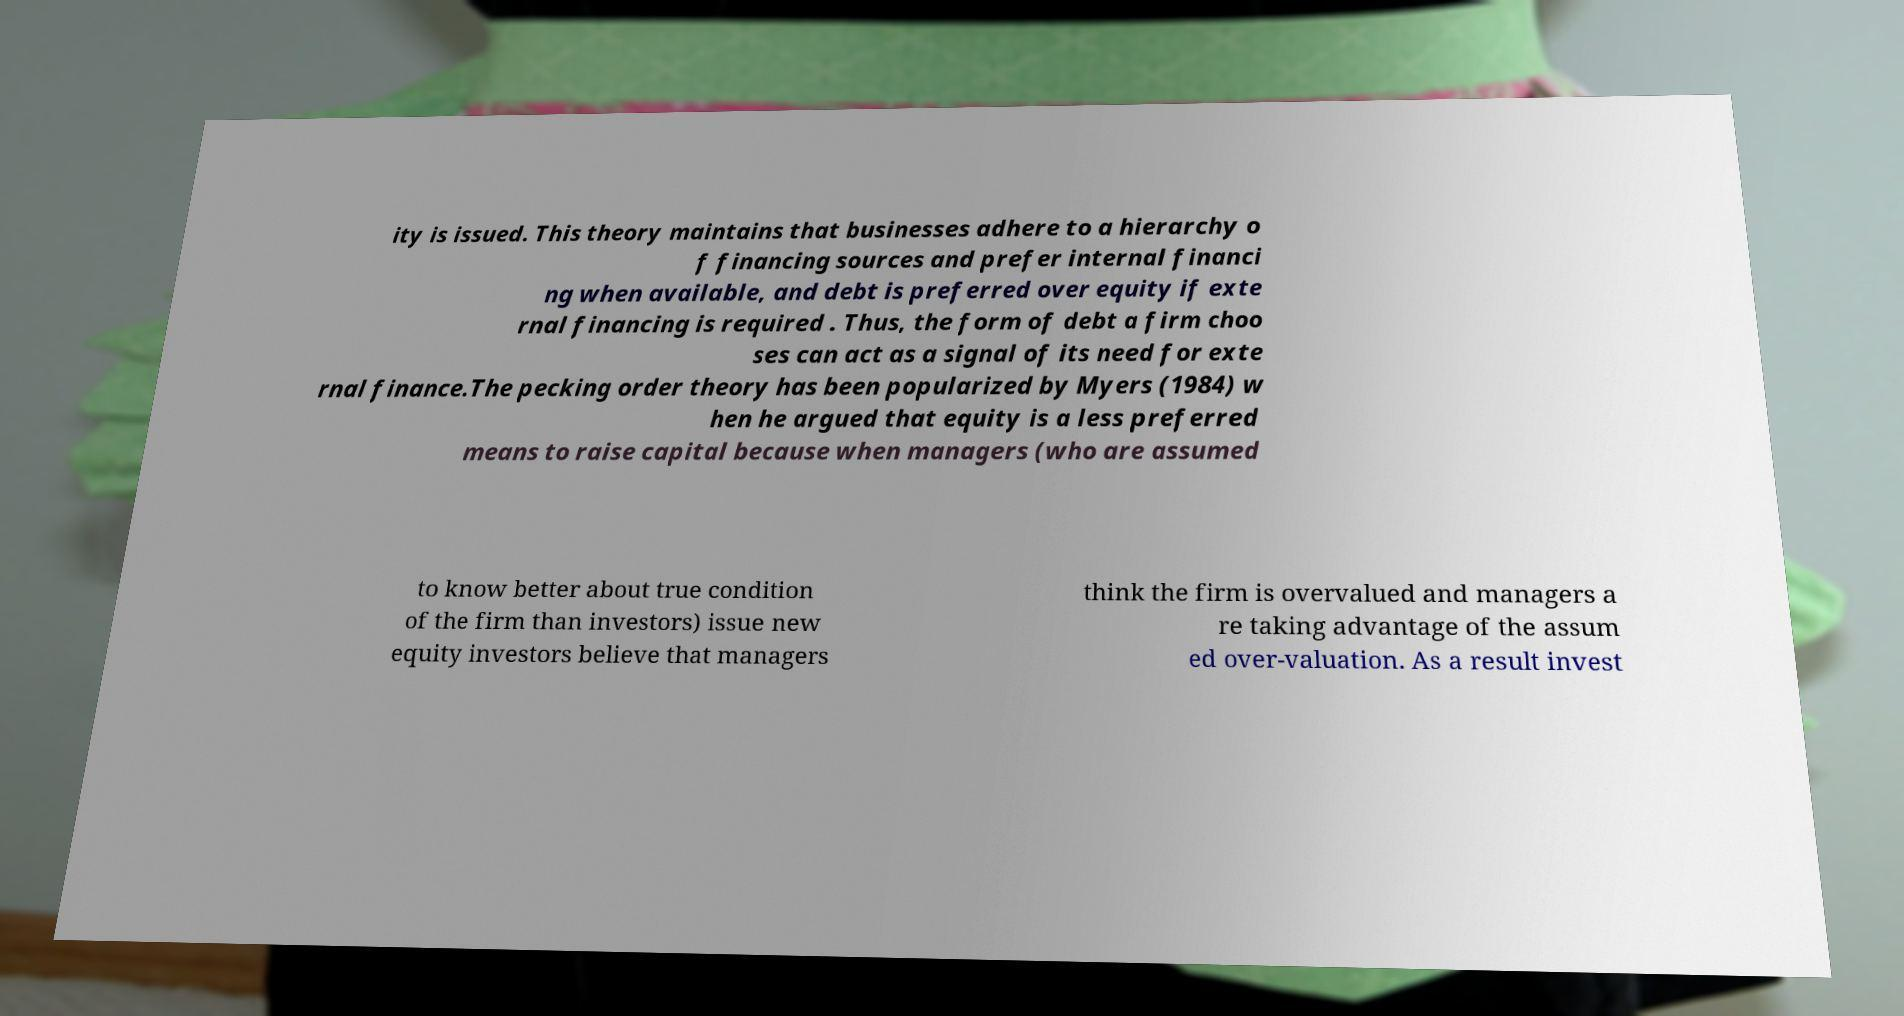What messages or text are displayed in this image? I need them in a readable, typed format. ity is issued. This theory maintains that businesses adhere to a hierarchy o f financing sources and prefer internal financi ng when available, and debt is preferred over equity if exte rnal financing is required . Thus, the form of debt a firm choo ses can act as a signal of its need for exte rnal finance.The pecking order theory has been popularized by Myers (1984) w hen he argued that equity is a less preferred means to raise capital because when managers (who are assumed to know better about true condition of the firm than investors) issue new equity investors believe that managers think the firm is overvalued and managers a re taking advantage of the assum ed over-valuation. As a result invest 